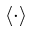<formula> <loc_0><loc_0><loc_500><loc_500>\langle \cdot \rangle</formula> 